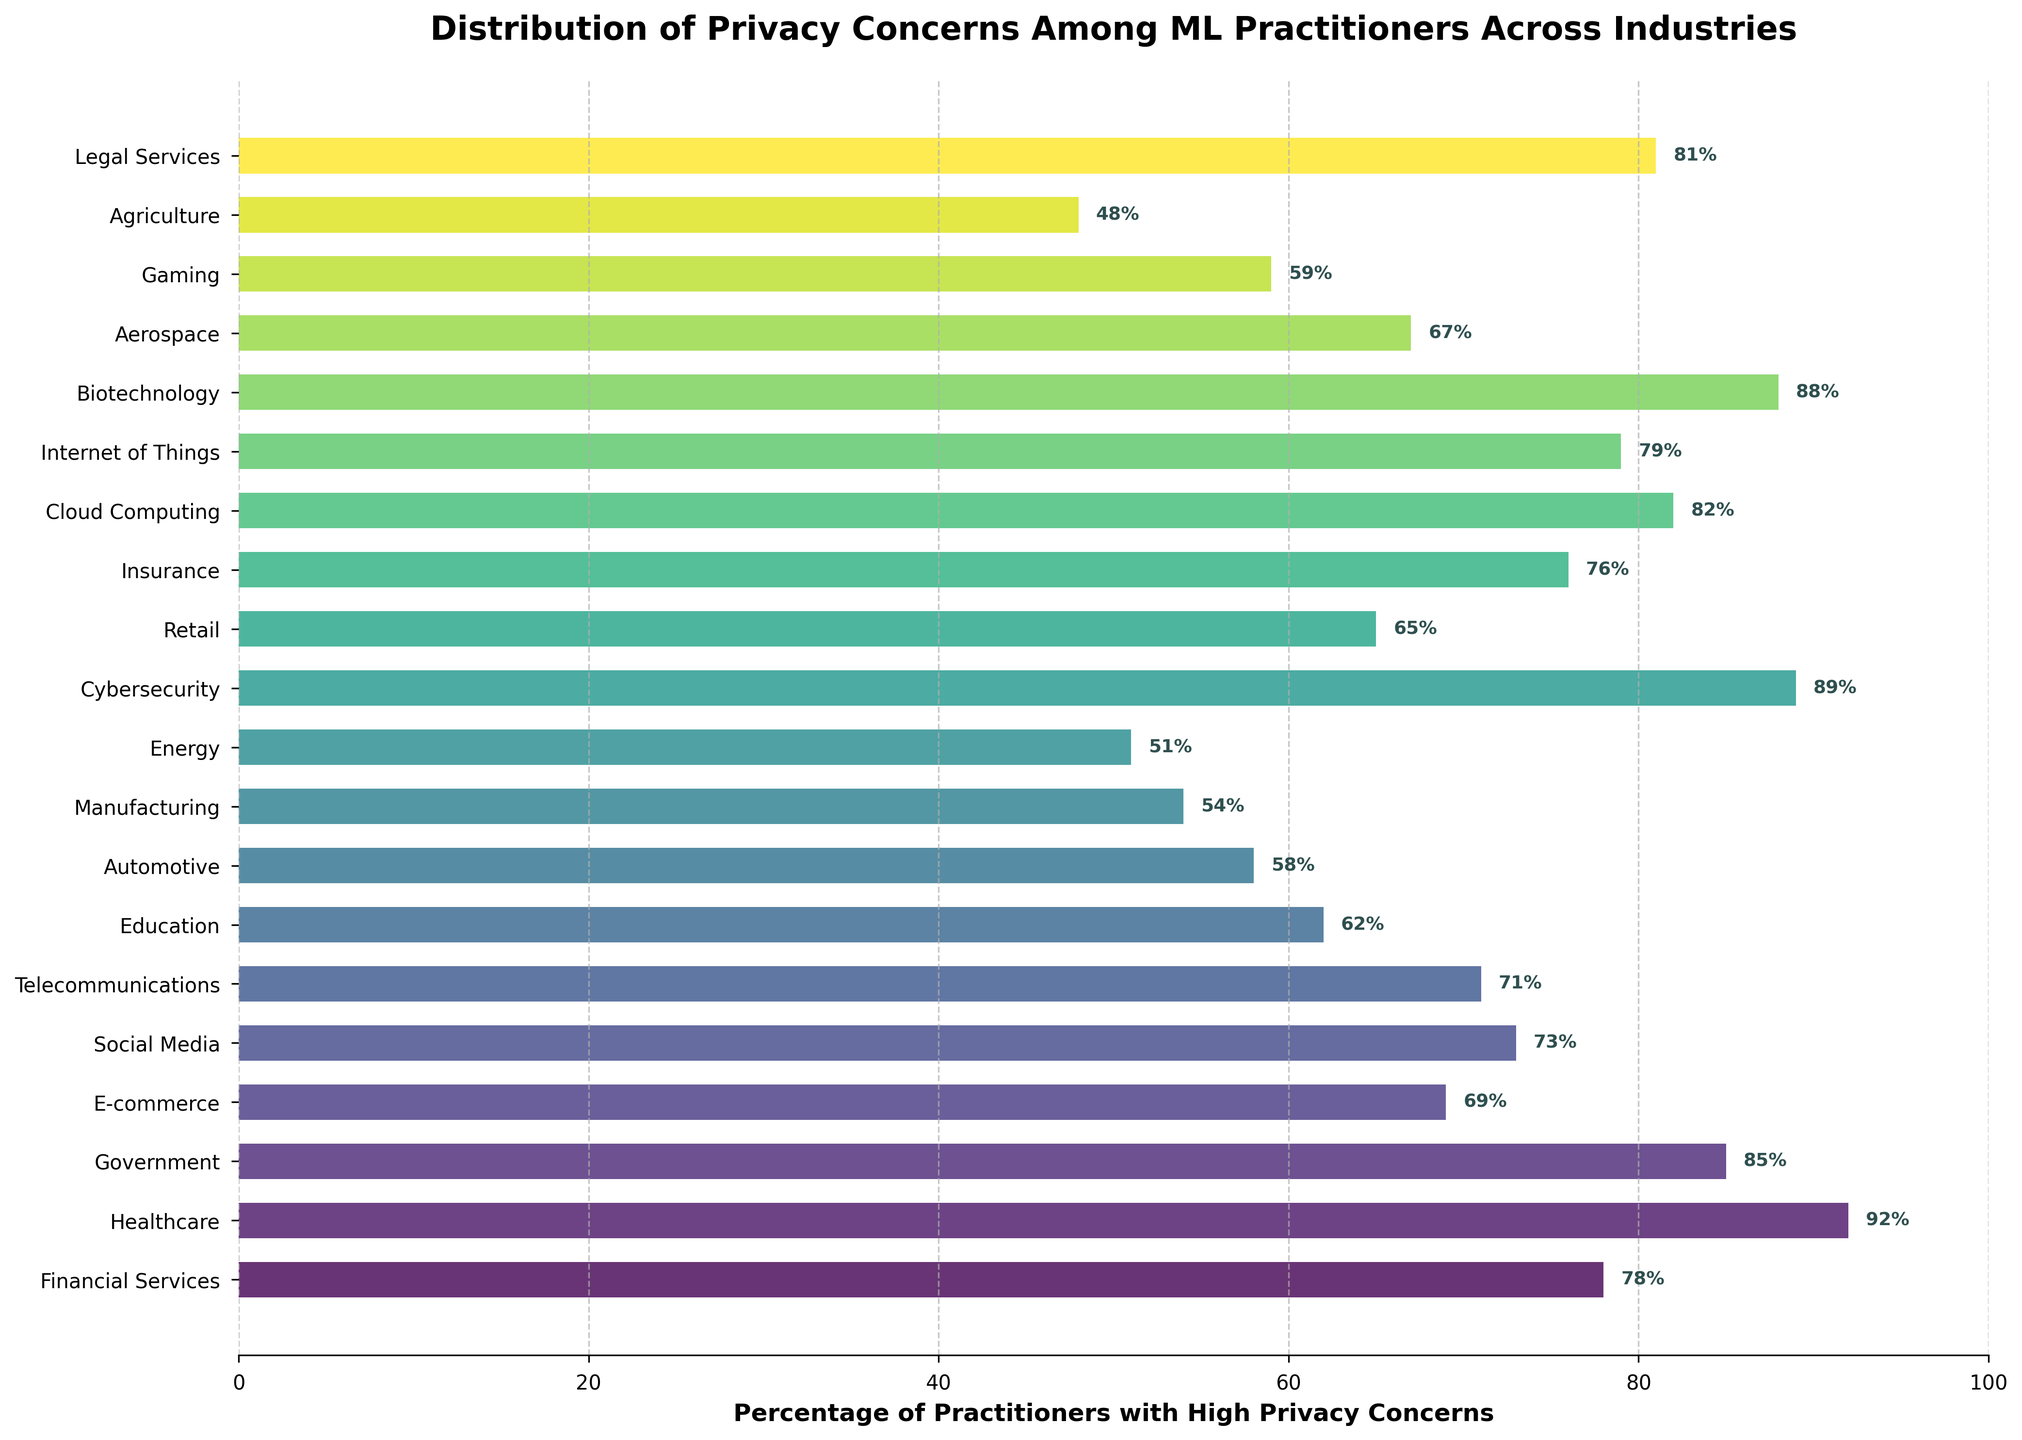Which industry has the highest percentage of practitioners with high privacy concerns? Look for the bar with the highest value in the chart.
Answer: Healthcare Which industry has the lowest percentage of practitioners with high privacy concerns? Identify the shortest bar in the chart.
Answer: Agriculture What is the difference in the percentage of practitioners with high privacy concerns between the Financial Services and Healthcare industries? Subtract the percentage of Financial Services from Healthcare (92% - 78%).
Answer: 14% How many industries have a percentage of practitioners with high privacy concerns greater than 70%? Count all bars that exceed the 70% mark.
Answer: 11 Are there more industries with a percentage of practitioners with high privacy concerns above 80% or below 60%? Count the number of industries above 80% and below 60% and compare.
Answer: Above 80% Which industries have a percentage of practitioners with high privacy concerns equal to or higher than 85%? Identify all bars at or above the 85% level.
Answer: Healthcare, Government, Cybersecurity, Biotechnology What is the average percentage of practitioners with high privacy concerns in the top 5 industries? Add the percentages of the top 5 industries (92, 89, 88, 85, 82) and divide by 5.
Answer: 87.2% Which industry has a higher percentage of practitioners with high privacy concerns: Cloud Computing or Telecommunications? Compare the heights of the bars for Cloud Computing (82%) and Telecommunications (71%).
Answer: Cloud Computing What is the combined percentage of practitioners with high privacy concerns in the sectors of E-commerce, Social Media, and Retail? Add the percentages of E-commerce (69%), Social Media (73%), and Retail (65%).
Answer: 207% Which industry has a percentage of practitioners with high privacy concerns closest to the average percentage across all industries? Calculate the average percentage over all industries and find the industry with the closest value.
Answer: Insurance 